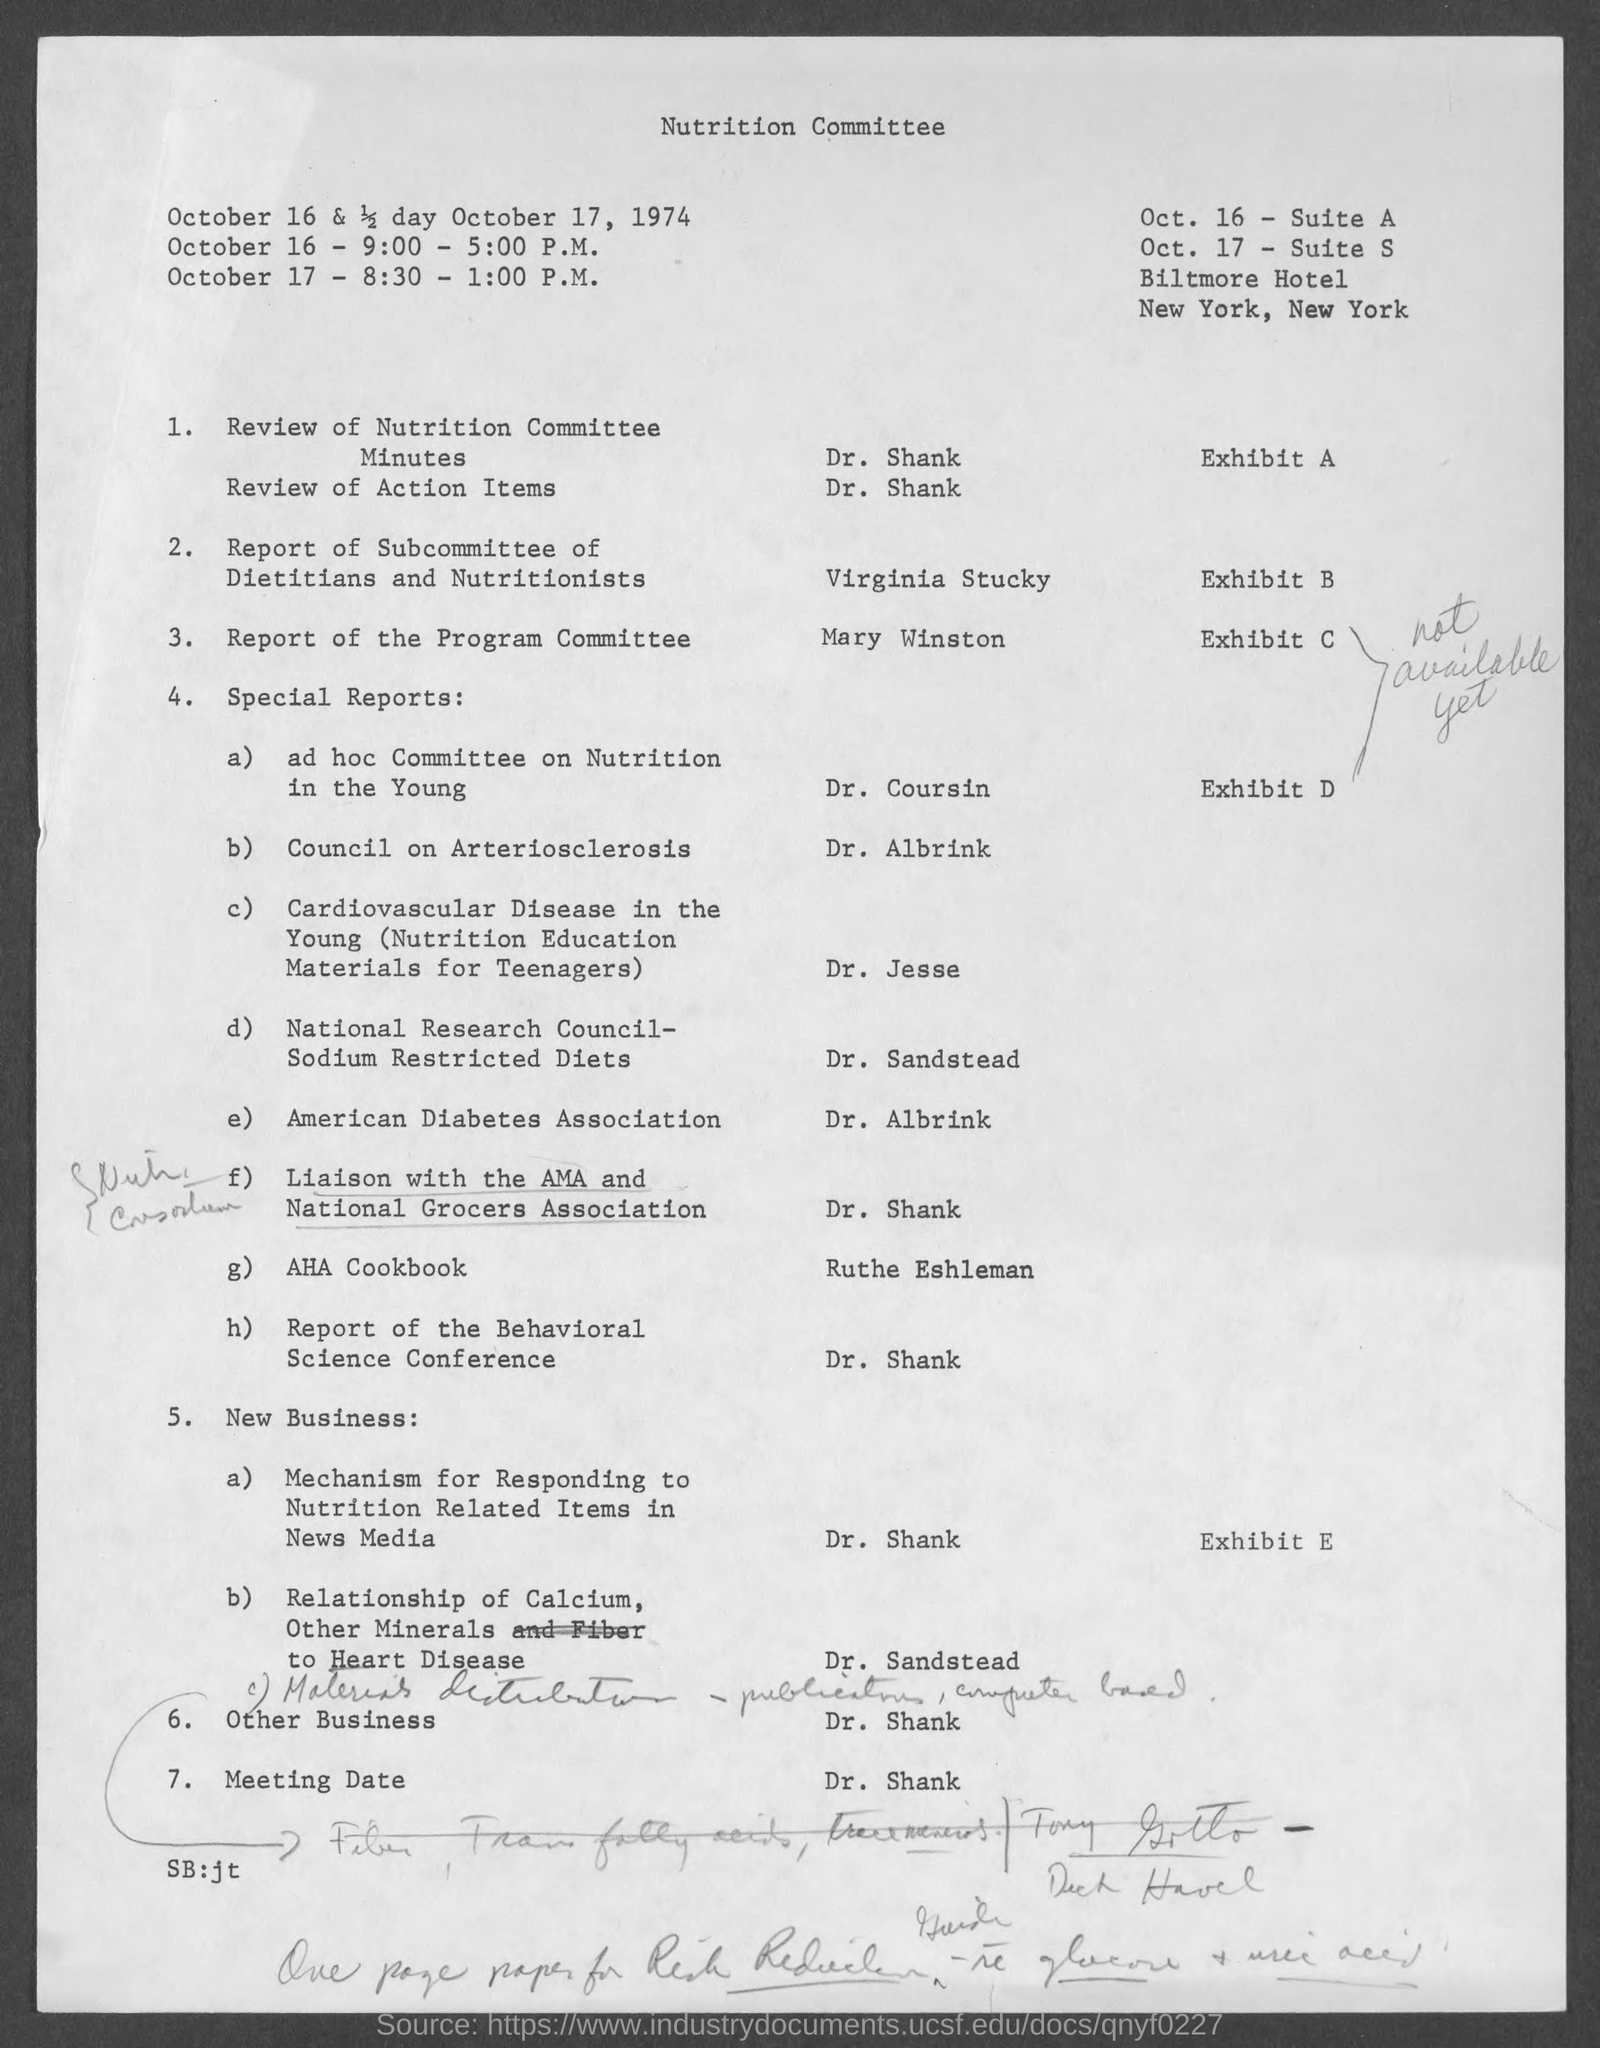Outline some significant characteristics in this image. It is being presented by Dr. Shank. The special reports on American Diabetes Association are being presented by Dr. Albrink. The report of the Behavioral Science Conference is being presented by Dr. Shank. The Report of the Program Committee will be presented by Mary Winston. 